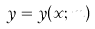<formula> <loc_0><loc_0><loc_500><loc_500>y = y ( x ; m )</formula> 